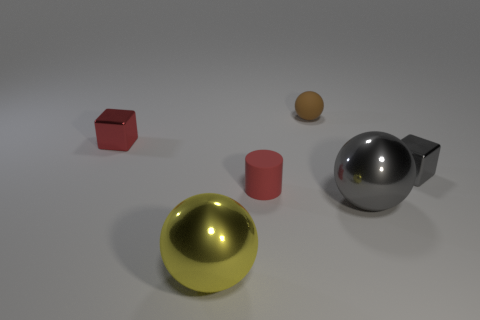Are there any other things that are the same shape as the tiny red rubber object?
Offer a very short reply. No. Is the material of the red object that is behind the tiny cylinder the same as the small brown thing that is behind the red matte thing?
Give a very brief answer. No. How many tiny shiny objects have the same color as the small rubber cylinder?
Your response must be concise. 1. The tiny thing that is both to the right of the cylinder and in front of the tiny matte sphere has what shape?
Your answer should be very brief. Cube. There is a thing that is in front of the rubber cylinder and on the right side of the yellow metal thing; what is its color?
Give a very brief answer. Gray. Are there more small metal things to the left of the red rubber cylinder than small rubber cylinders behind the gray metallic block?
Give a very brief answer. Yes. There is a metal block that is to the right of the yellow shiny object; what color is it?
Offer a terse response. Gray. Does the matte thing that is behind the tiny gray object have the same shape as the big metallic object to the right of the big yellow shiny thing?
Your response must be concise. Yes. Is there a gray cube that has the same size as the red rubber thing?
Provide a succinct answer. Yes. There is a small red thing behind the gray metallic block; what material is it?
Give a very brief answer. Metal. 